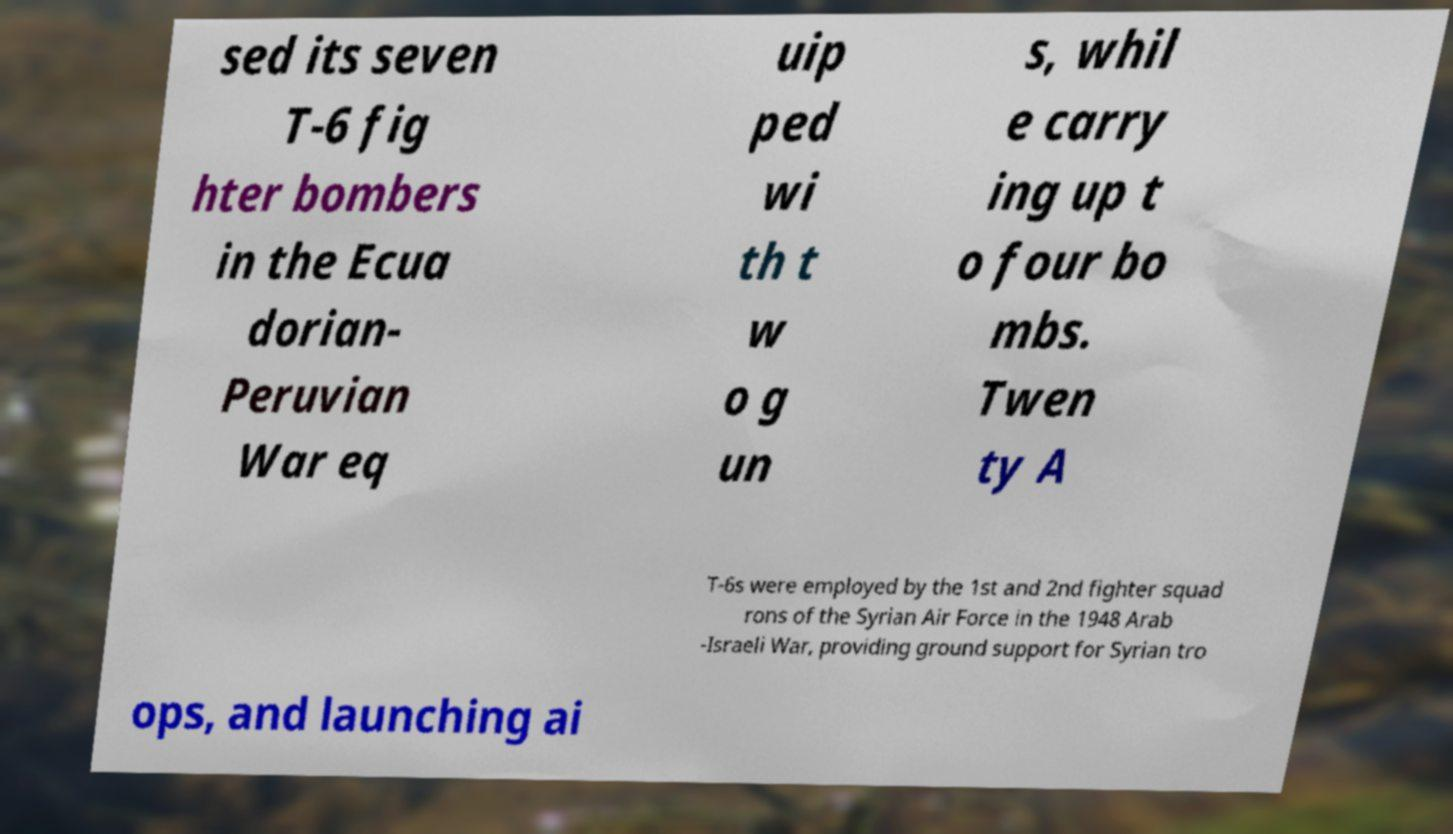What messages or text are displayed in this image? I need them in a readable, typed format. sed its seven T-6 fig hter bombers in the Ecua dorian- Peruvian War eq uip ped wi th t w o g un s, whil e carry ing up t o four bo mbs. Twen ty A T-6s were employed by the 1st and 2nd fighter squad rons of the Syrian Air Force in the 1948 Arab -Israeli War, providing ground support for Syrian tro ops, and launching ai 